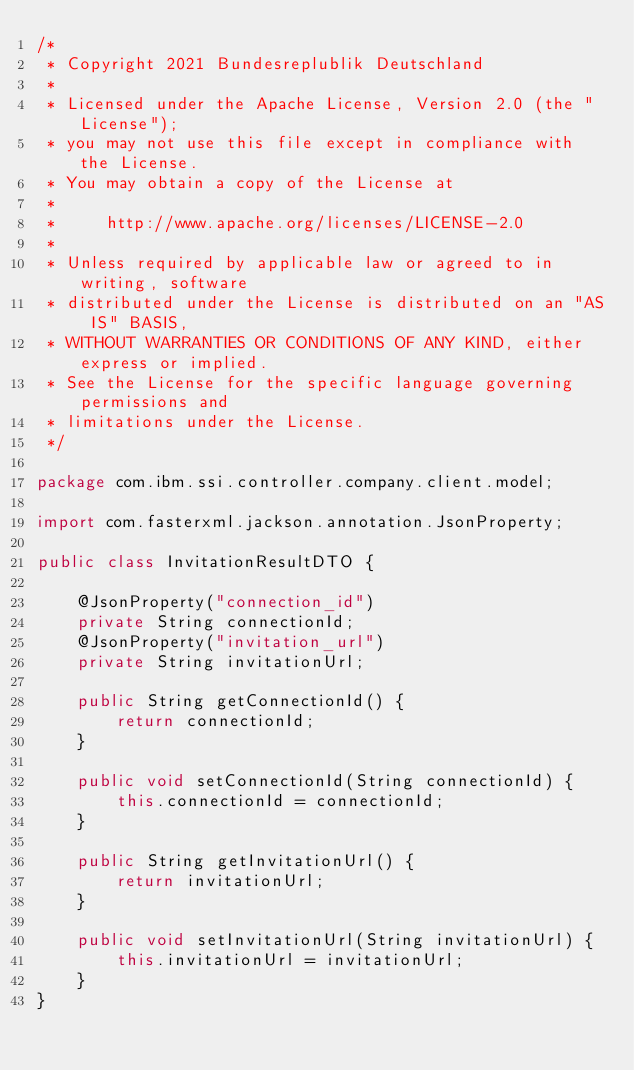Convert code to text. <code><loc_0><loc_0><loc_500><loc_500><_Java_>/*
 * Copyright 2021 Bundesreplublik Deutschland
 *
 * Licensed under the Apache License, Version 2.0 (the "License");
 * you may not use this file except in compliance with the License.
 * You may obtain a copy of the License at
 *
 *     http://www.apache.org/licenses/LICENSE-2.0
 *
 * Unless required by applicable law or agreed to in writing, software
 * distributed under the License is distributed on an "AS IS" BASIS,
 * WITHOUT WARRANTIES OR CONDITIONS OF ANY KIND, either express or implied.
 * See the License for the specific language governing permissions and
 * limitations under the License.
 */

package com.ibm.ssi.controller.company.client.model;

import com.fasterxml.jackson.annotation.JsonProperty;

public class InvitationResultDTO {

    @JsonProperty("connection_id")
    private String connectionId;
    @JsonProperty("invitation_url")
    private String invitationUrl;

    public String getConnectionId() {
        return connectionId;
    }

    public void setConnectionId(String connectionId) {
        this.connectionId = connectionId;
    }

    public String getInvitationUrl() {
        return invitationUrl;
    }

    public void setInvitationUrl(String invitationUrl) {
        this.invitationUrl = invitationUrl;
    }
}
</code> 